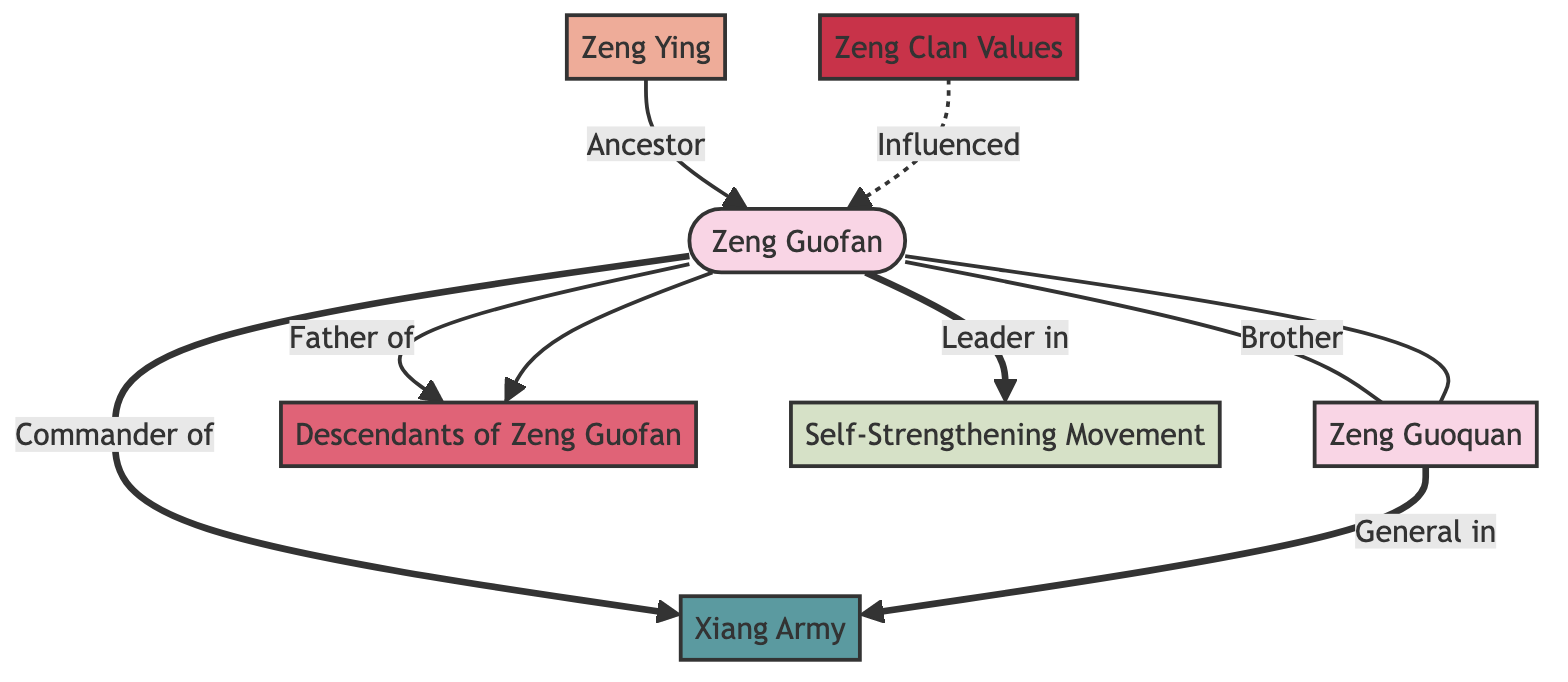What is the relationship between Zeng Guofan and Zeng Guoquan? The diagram shows a direct connection labeled "Brother" between Zeng Guofan and Zeng Guoquan. Thus, they are siblings.
Answer: Brother Who influenced Zeng Guofan according to the diagram? The diagram indicates a dotted line labeled "Influenced" pointing from Zeng Clan Values to Zeng Guofan, suggesting that Zeng Clan Values had an influence on him.
Answer: Zeng Clan Values How many descendants of Zeng Guofan are pictured? The diagram explicitly depicts one node labeled "Descendants of Zeng Guofan," indicating there are descendants represented but not specified separately.
Answer: 1 What role did Zeng Guofan have in the Xiang Army? The diagram shows a connection indicating "Commander of" between Zeng Guofan and Xiang Army, which represents his leadership position within that military group.
Answer: Commander How is Zeng Guoquan related to the Xiang Army? The diagram states a relationship "General in" from Zeng Guoquan to Xiang Army, indicating his position within the military structure as a general.
Answer: General What movement was Zeng Guofan a leader in? The specified connection in the diagram labeled "Leader in" links Zeng Guofan to Self-Strengthening Movement, indicating his role in that historical initiative.
Answer: Self-Strengthening Movement Which ancestor is mentioned in the diagram as relating to Zeng Guofan? The diagram indicates a direct connection labeled "Ancestor" from Zeng Ying to Zeng Guofan, identifying Zeng Ying as his ancestor.
Answer: Zeng Ying How many total nodes are included in the diagram? By counting each distinct labeled node, we find there are a total of six nodes present in the diagram structure.
Answer: 6 What kind of movement is indicated in the diagram associated with Zeng Guofan? The labeled node "Self-Strengthening Movement" suggests that the movement associated with Zeng Guofan is a historical movement aiming for national modernization.
Answer: Historical 